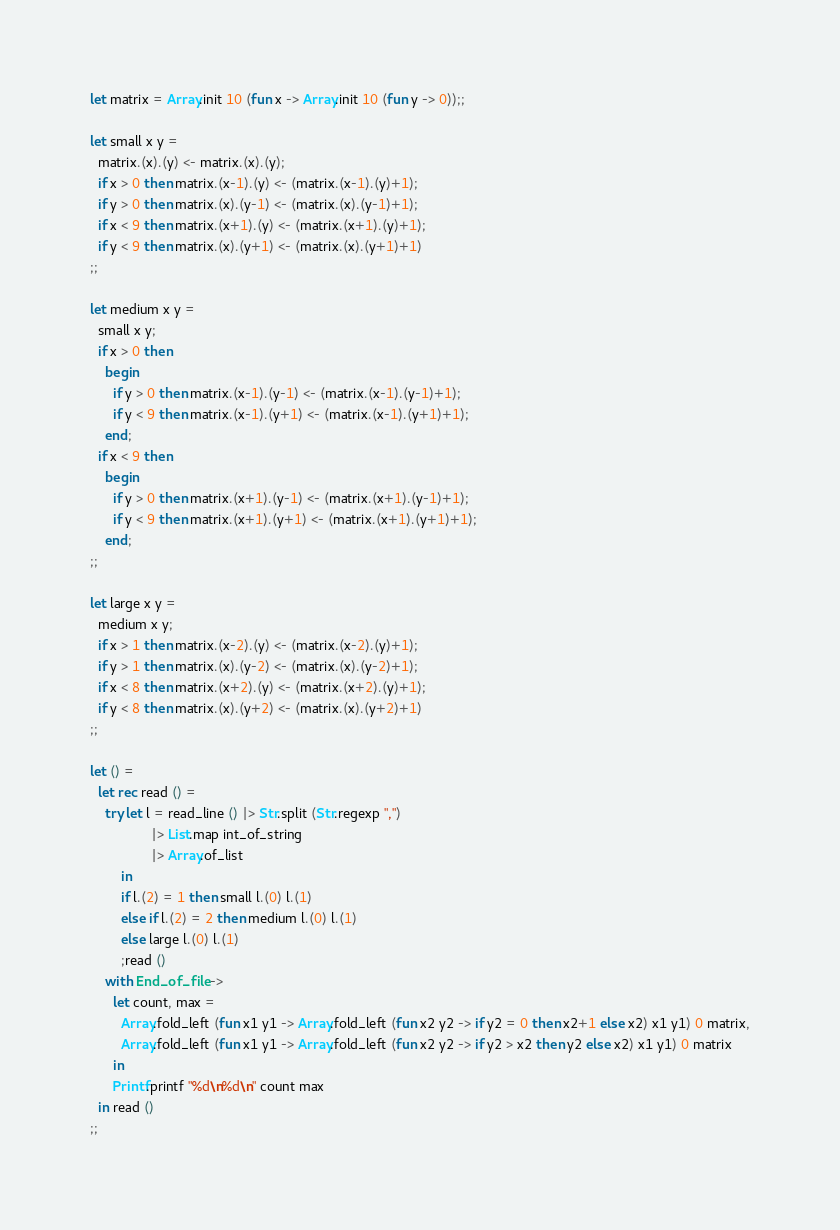<code> <loc_0><loc_0><loc_500><loc_500><_OCaml_>let matrix = Array.init 10 (fun x -> Array.init 10 (fun y -> 0));;

let small x y =
  matrix.(x).(y) <- matrix.(x).(y);
  if x > 0 then matrix.(x-1).(y) <- (matrix.(x-1).(y)+1);
  if y > 0 then matrix.(x).(y-1) <- (matrix.(x).(y-1)+1);
  if x < 9 then matrix.(x+1).(y) <- (matrix.(x+1).(y)+1);
  if y < 9 then matrix.(x).(y+1) <- (matrix.(x).(y+1)+1)
;;

let medium x y =
  small x y;
  if x > 0 then
    begin
      if y > 0 then matrix.(x-1).(y-1) <- (matrix.(x-1).(y-1)+1);
      if y < 9 then matrix.(x-1).(y+1) <- (matrix.(x-1).(y+1)+1);
    end;
  if x < 9 then
    begin
      if y > 0 then matrix.(x+1).(y-1) <- (matrix.(x+1).(y-1)+1);
      if y < 9 then matrix.(x+1).(y+1) <- (matrix.(x+1).(y+1)+1);
    end;
;;

let large x y =
  medium x y;
  if x > 1 then matrix.(x-2).(y) <- (matrix.(x-2).(y)+1);
  if y > 1 then matrix.(x).(y-2) <- (matrix.(x).(y-2)+1);
  if x < 8 then matrix.(x+2).(y) <- (matrix.(x+2).(y)+1);
  if y < 8 then matrix.(x).(y+2) <- (matrix.(x).(y+2)+1)
;;

let () =
  let rec read () =
    try let l = read_line () |> Str.split (Str.regexp ",")
                |> List.map int_of_string
                |> Array.of_list
        in
        if l.(2) = 1 then small l.(0) l.(1)
        else if l.(2) = 2 then medium l.(0) l.(1)
        else large l.(0) l.(1)
        ;read ()
    with End_of_file ->
      let count, max =
        Array.fold_left (fun x1 y1 -> Array.fold_left (fun x2 y2 -> if y2 = 0 then x2+1 else x2) x1 y1) 0 matrix,
        Array.fold_left (fun x1 y1 -> Array.fold_left (fun x2 y2 -> if y2 > x2 then y2 else x2) x1 y1) 0 matrix
      in
      Printf.printf "%d\n%d\n" count max
  in read ()
;;</code> 